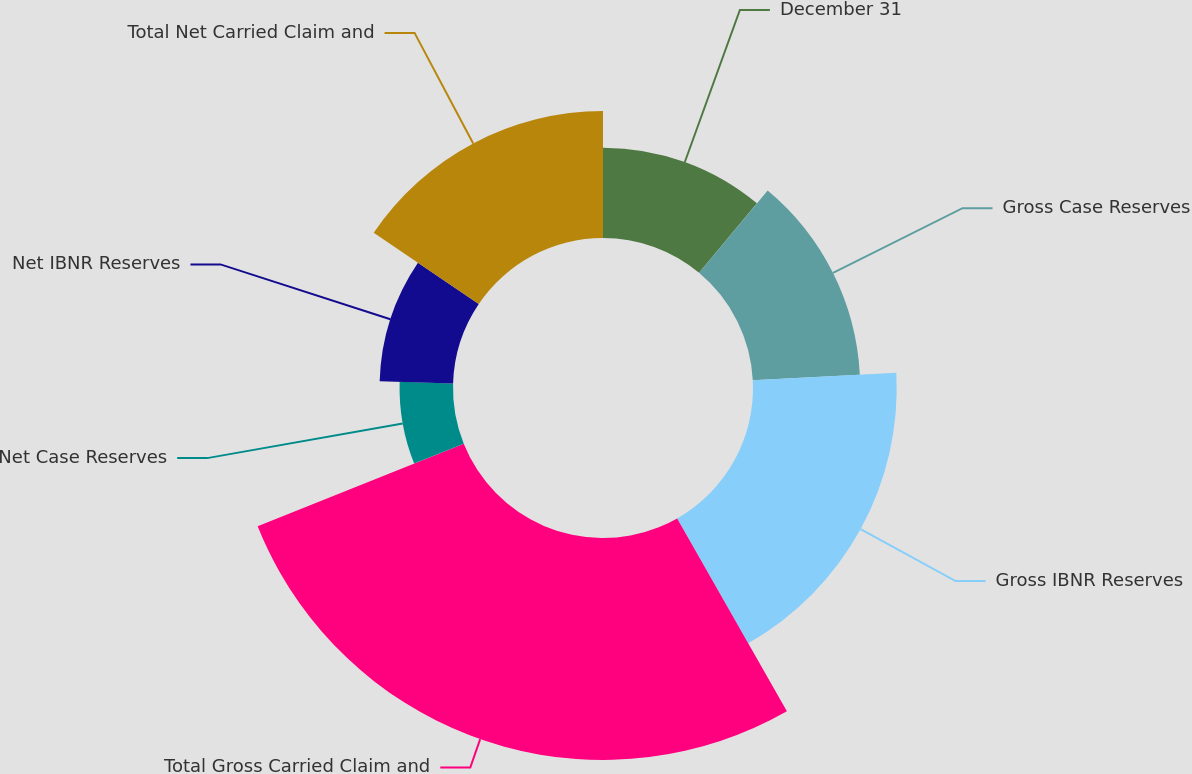Convert chart to OTSL. <chart><loc_0><loc_0><loc_500><loc_500><pie_chart><fcel>December 31<fcel>Gross Case Reserves<fcel>Gross IBNR Reserves<fcel>Total Gross Carried Claim and<fcel>Net Case Reserves<fcel>Net IBNR Reserves<fcel>Total Net Carried Claim and<nl><fcel>11.06%<fcel>13.12%<fcel>17.59%<fcel>27.17%<fcel>6.54%<fcel>8.99%<fcel>15.53%<nl></chart> 